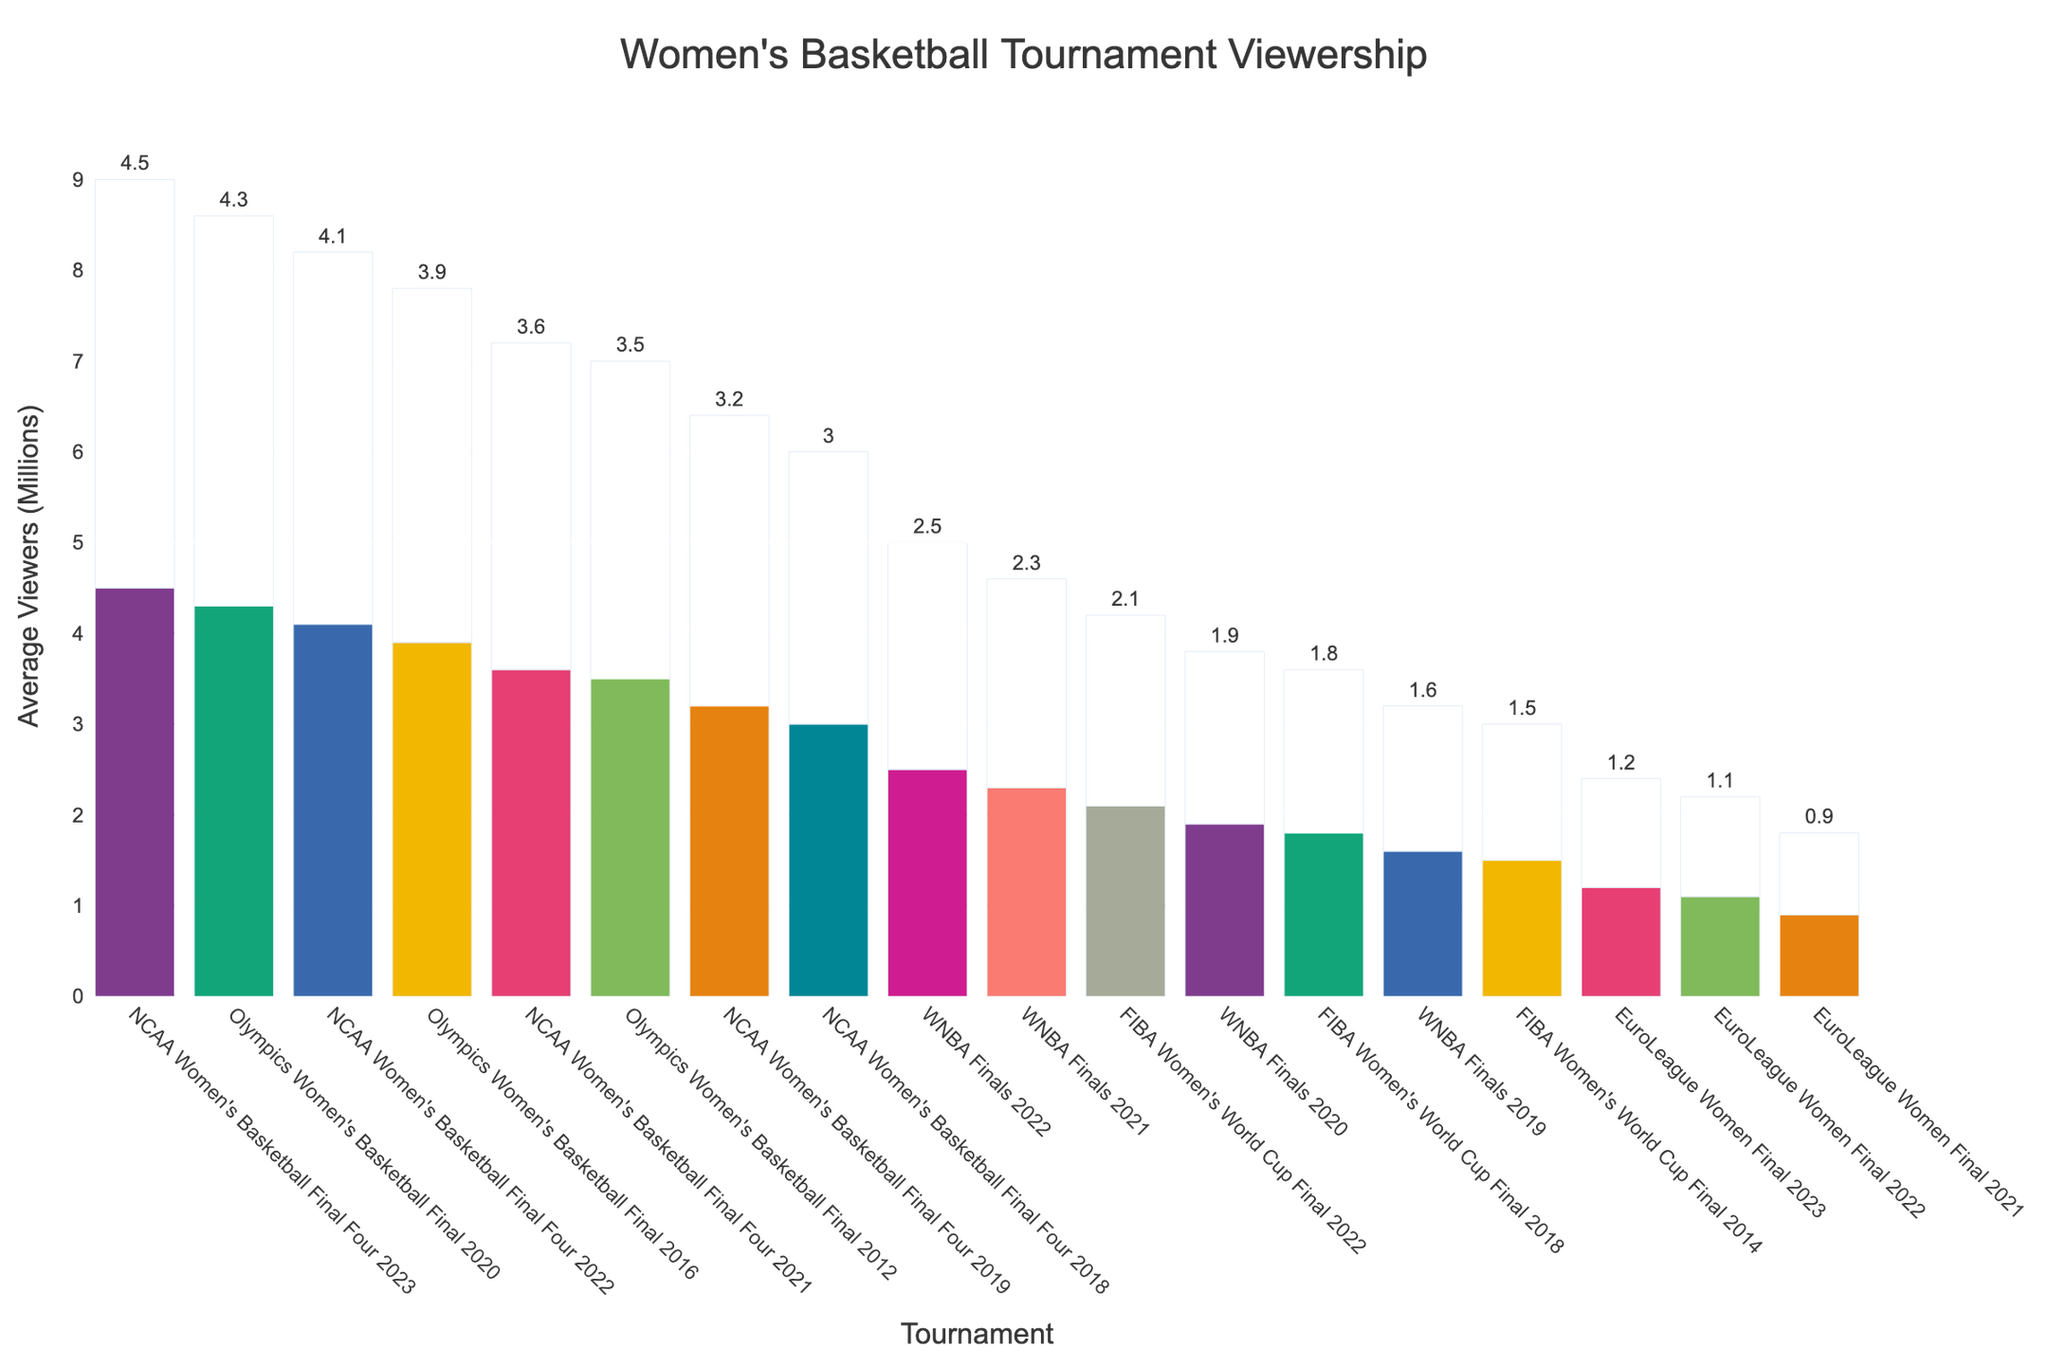Which event had the highest average viewership? The highest bar in the chart corresponds to "NCAA Women's Basketball Final Four 2023," indicating it had the highest average viewership.
Answer: NCAA Women's Basketball Final Four 2023 What has been the trend in viewership for the Olympics Women's Basketball Final over the last three events? By observing the bars labeled "Olympics Women's Basketball Final 2020," "Olympics Women's Basketball Final 2016," and "Olympics Women's Basketball Final 2012," it is clear that the average viewership increased from 3.5 million (2012) to 3.9 million (2016) and then to 4.3 million (2020).
Answer: Increasing trend Which event had lower average viewership, the FIBA Women's World Cup Final in 2022 or the WNBA Finals in 2022? Both the "FIBA Women's World Cup Final 2022" and "WNBA Finals 2022" bars can be compared. The height of the bar for the "FIBA Women's World Cup Final 2022" with 2.1 million viewers is shorter than the "WNBA Finals 2022" with 2.5 million viewers.
Answer: FIBA Women's World Cup Final 2022 What is the difference in viewership between the lowest viewed and highest viewed events? The lowest viewership is for "EuroLeague Women Final 2021" with 0.9 million viewers, and the highest is "NCAA Women's Basketball Final Four 2023" with 4.5 million viewers. The difference is 4.5 - 0.9 = 3.6 million viewers.
Answer: 3.6 million viewers How does the viewership of the NCAA Women's Basketball Final Four in 2021 compare to the WNBA Finals in 2022? The bars for "NCAA Women's Basketball Final Four 2021" and "WNBA Finals 2022" show that the former has 3.6 million viewers, which is higher than the 2.5 million viewers of the latter.
Answer: NCAA Women's Basketball Final Four 2021 has higher viewership What percentage increase in viewership did the NCAA Women's Basketball Final Four have from 2019 to 2023? The viewership increased from 3.2 million in 2019 to 4.5 million in 2023. The percentage increase is calculated as (4.5 - 3.2) / 3.2 * 100% = 40.625%.
Answer: Approximately 40.6% What event had the closest viewership to 2 million viewers, and what was the exact viewership? By examining the bars around the 2 million viewers mark, "WNBA Finals 2020" is closest with 1.9 million viewers.
Answer: WNBA Finals 2020, 1.9 million viewers By how much did the viewership for the WNBA Finals increase from 2019 to 2022? The viewership for "WNBA Finals 2019" was 1.6 million, and for "WNBA Finals 2022" was 2.5 million. The increase is 2.5 - 1.6 = 0.9 million viewers.
Answer: 0.9 million viewers Which major women's basketball tournament had consistent year-over-year growth from 2021 to 2023? Looking at the NCAA Women's Basketball Final Four from 2021 (3.6 million), 2022 (4.1 million), and 2023 (4.5 million), each year shows an increase in viewership.
Answer: NCAA Women's Basketball Final Four 